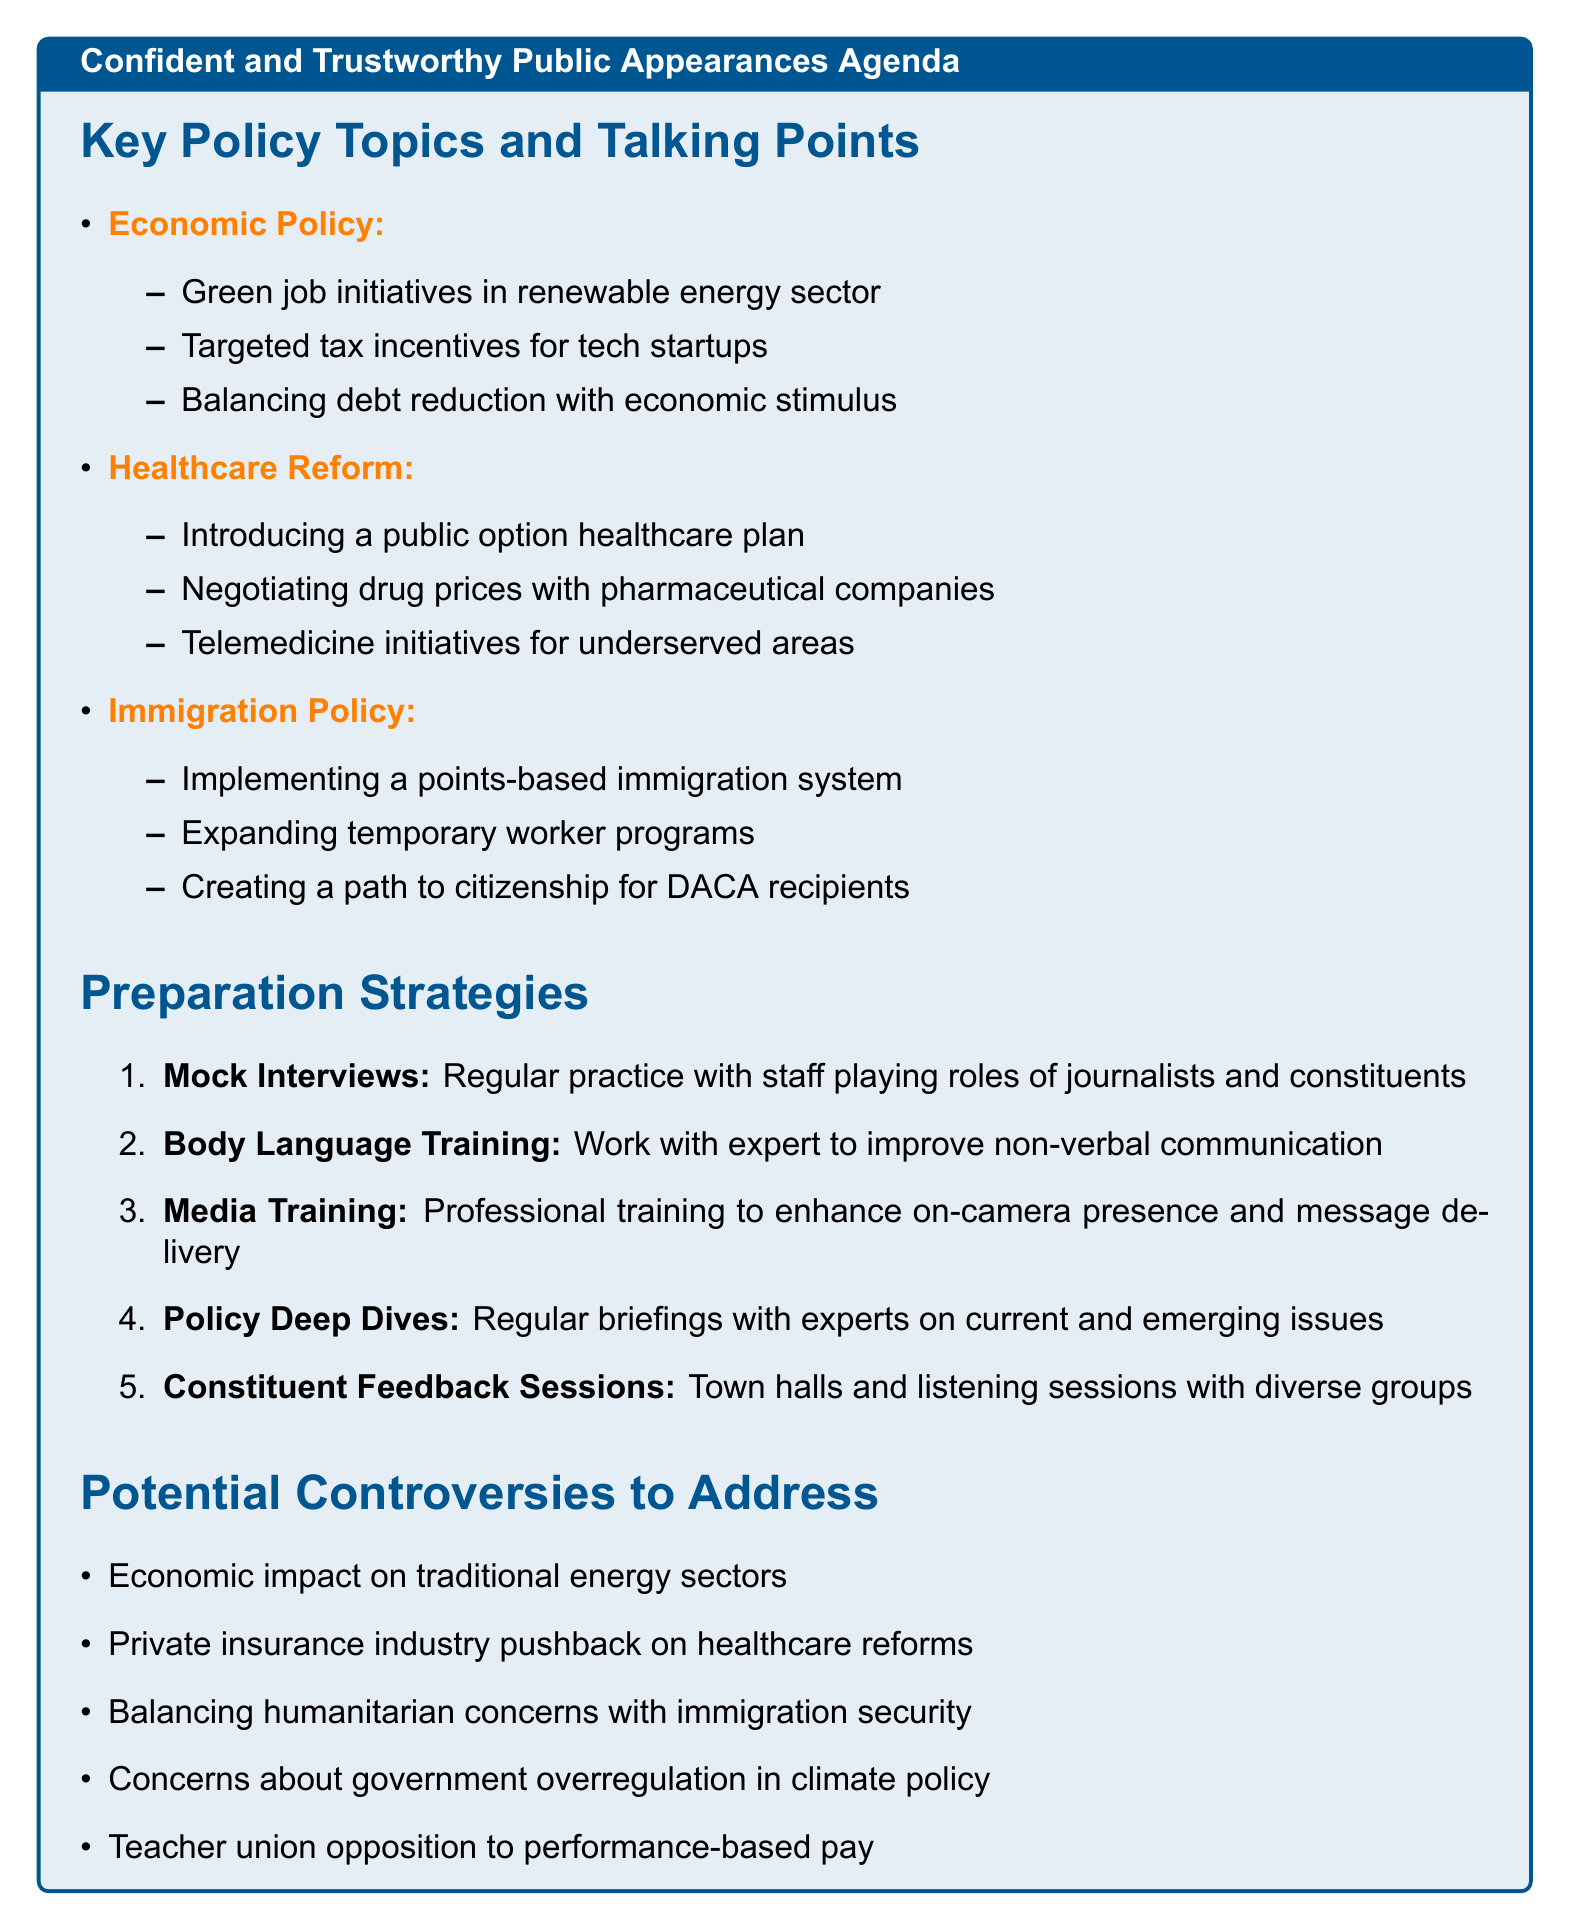what are the updated points for Economic Policy? The updated points for Economic Policy are listed in the agenda, including green job initiatives, targeted tax incentives, and balancing debt reduction.
Answer: green job initiatives in renewable energy sector, targeted tax incentives for tech startups, balancing debt reduction with economic stimulus how many preparation strategies are mentioned in the document? The document lists a total of five distinct preparation strategies for improving public speaking and engagement.
Answer: 5 what is one potential controversy related to Healthcare Reform? The document identifies private insurance industry pushback as a potential controversy related to Healthcare Reform.
Answer: Private insurance industry pushback what is a benefit of conducting mock interviews? The document states that one key benefit of mock interviews is that it improves the ability to handle unexpected questions.
Answer: Improves ability to handle unexpected questions what is the title of the agenda? The document contains the title at the beginning of the agenda, which outlines the main theme and focus areas for public appearances.
Answer: Confident and Trustworthy Public Appearances Agenda what is one updated point under Climate Change? The updated points under Climate Change include ambitious targets aimed at reducing carbon emissions as a strategy to combat climate change.
Answer: Setting aggressive carbon neutrality targets 